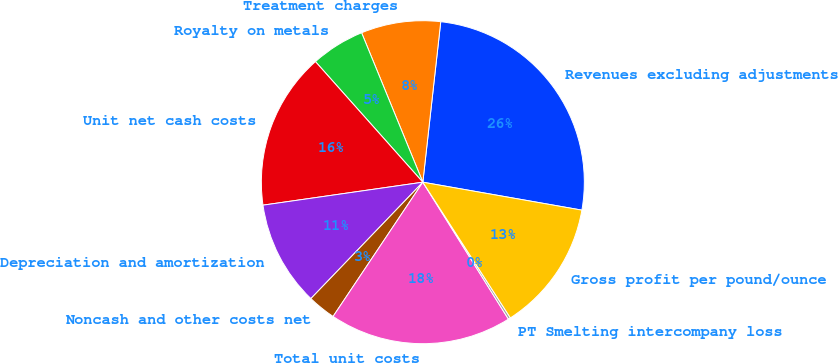Convert chart to OTSL. <chart><loc_0><loc_0><loc_500><loc_500><pie_chart><fcel>Revenues excluding adjustments<fcel>Treatment charges<fcel>Royalty on metals<fcel>Unit net cash costs<fcel>Depreciation and amortization<fcel>Noncash and other costs net<fcel>Total unit costs<fcel>PT Smelting intercompany loss<fcel>Gross profit per pound/ounce<nl><fcel>26.0%<fcel>7.96%<fcel>5.39%<fcel>15.69%<fcel>10.54%<fcel>2.81%<fcel>18.27%<fcel>0.23%<fcel>13.11%<nl></chart> 